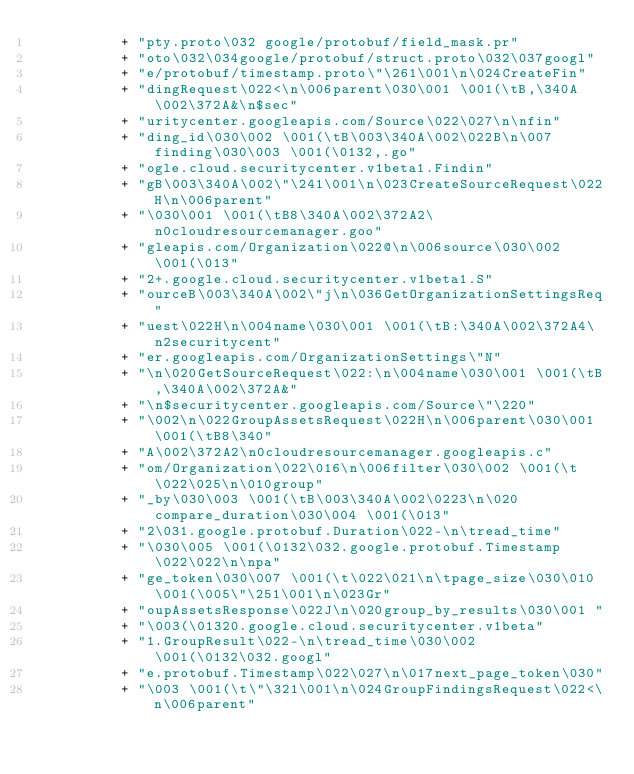<code> <loc_0><loc_0><loc_500><loc_500><_Java_>          + "pty.proto\032 google/protobuf/field_mask.pr"
          + "oto\032\034google/protobuf/struct.proto\032\037googl"
          + "e/protobuf/timestamp.proto\"\261\001\n\024CreateFin"
          + "dingRequest\022<\n\006parent\030\001 \001(\tB,\340A\002\372A&\n$sec"
          + "uritycenter.googleapis.com/Source\022\027\n\nfin"
          + "ding_id\030\002 \001(\tB\003\340A\002\022B\n\007finding\030\003 \001(\0132,.go"
          + "ogle.cloud.securitycenter.v1beta1.Findin"
          + "gB\003\340A\002\"\241\001\n\023CreateSourceRequest\022H\n\006parent"
          + "\030\001 \001(\tB8\340A\002\372A2\n0cloudresourcemanager.goo"
          + "gleapis.com/Organization\022@\n\006source\030\002 \001(\013"
          + "2+.google.cloud.securitycenter.v1beta1.S"
          + "ourceB\003\340A\002\"j\n\036GetOrganizationSettingsReq"
          + "uest\022H\n\004name\030\001 \001(\tB:\340A\002\372A4\n2securitycent"
          + "er.googleapis.com/OrganizationSettings\"N"
          + "\n\020GetSourceRequest\022:\n\004name\030\001 \001(\tB,\340A\002\372A&"
          + "\n$securitycenter.googleapis.com/Source\"\220"
          + "\002\n\022GroupAssetsRequest\022H\n\006parent\030\001 \001(\tB8\340"
          + "A\002\372A2\n0cloudresourcemanager.googleapis.c"
          + "om/Organization\022\016\n\006filter\030\002 \001(\t\022\025\n\010group"
          + "_by\030\003 \001(\tB\003\340A\002\0223\n\020compare_duration\030\004 \001(\013"
          + "2\031.google.protobuf.Duration\022-\n\tread_time"
          + "\030\005 \001(\0132\032.google.protobuf.Timestamp\022\022\n\npa"
          + "ge_token\030\007 \001(\t\022\021\n\tpage_size\030\010 \001(\005\"\251\001\n\023Gr"
          + "oupAssetsResponse\022J\n\020group_by_results\030\001 "
          + "\003(\01320.google.cloud.securitycenter.v1beta"
          + "1.GroupResult\022-\n\tread_time\030\002 \001(\0132\032.googl"
          + "e.protobuf.Timestamp\022\027\n\017next_page_token\030"
          + "\003 \001(\t\"\321\001\n\024GroupFindingsRequest\022<\n\006parent"</code> 